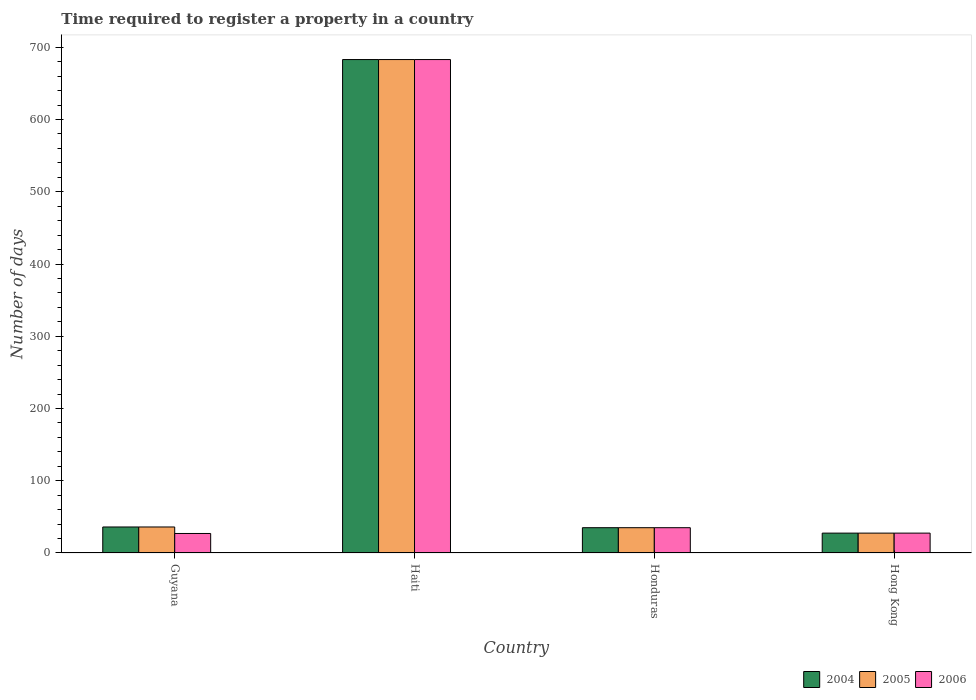How many different coloured bars are there?
Offer a terse response. 3. How many groups of bars are there?
Keep it short and to the point. 4. Are the number of bars per tick equal to the number of legend labels?
Provide a short and direct response. Yes. How many bars are there on the 1st tick from the right?
Offer a terse response. 3. What is the label of the 4th group of bars from the left?
Offer a very short reply. Hong Kong. In how many cases, is the number of bars for a given country not equal to the number of legend labels?
Ensure brevity in your answer.  0. What is the number of days required to register a property in 2006 in Haiti?
Make the answer very short. 683. Across all countries, what is the maximum number of days required to register a property in 2004?
Provide a succinct answer. 683. Across all countries, what is the minimum number of days required to register a property in 2004?
Your response must be concise. 27.5. In which country was the number of days required to register a property in 2004 maximum?
Ensure brevity in your answer.  Haiti. In which country was the number of days required to register a property in 2004 minimum?
Ensure brevity in your answer.  Hong Kong. What is the total number of days required to register a property in 2004 in the graph?
Provide a succinct answer. 781.5. What is the difference between the number of days required to register a property in 2006 in Guyana and that in Haiti?
Make the answer very short. -656. What is the average number of days required to register a property in 2004 per country?
Ensure brevity in your answer.  195.38. In how many countries, is the number of days required to register a property in 2004 greater than 80 days?
Your answer should be compact. 1. What is the ratio of the number of days required to register a property in 2005 in Honduras to that in Hong Kong?
Make the answer very short. 1.27. Is the number of days required to register a property in 2005 in Guyana less than that in Hong Kong?
Offer a very short reply. No. What is the difference between the highest and the lowest number of days required to register a property in 2005?
Keep it short and to the point. 655.5. In how many countries, is the number of days required to register a property in 2006 greater than the average number of days required to register a property in 2006 taken over all countries?
Ensure brevity in your answer.  1. What does the 1st bar from the left in Hong Kong represents?
Your answer should be compact. 2004. What does the 2nd bar from the right in Honduras represents?
Keep it short and to the point. 2005. How many bars are there?
Ensure brevity in your answer.  12. Are all the bars in the graph horizontal?
Offer a very short reply. No. How many countries are there in the graph?
Keep it short and to the point. 4. What is the difference between two consecutive major ticks on the Y-axis?
Offer a very short reply. 100. Does the graph contain any zero values?
Offer a very short reply. No. How are the legend labels stacked?
Provide a short and direct response. Horizontal. What is the title of the graph?
Provide a succinct answer. Time required to register a property in a country. Does "1964" appear as one of the legend labels in the graph?
Provide a succinct answer. No. What is the label or title of the Y-axis?
Provide a short and direct response. Number of days. What is the Number of days in 2004 in Guyana?
Provide a short and direct response. 36. What is the Number of days of 2006 in Guyana?
Give a very brief answer. 27. What is the Number of days in 2004 in Haiti?
Offer a very short reply. 683. What is the Number of days of 2005 in Haiti?
Provide a succinct answer. 683. What is the Number of days in 2006 in Haiti?
Give a very brief answer. 683. What is the Number of days of 2006 in Honduras?
Provide a short and direct response. 35. What is the Number of days in 2004 in Hong Kong?
Give a very brief answer. 27.5. What is the Number of days in 2005 in Hong Kong?
Ensure brevity in your answer.  27.5. Across all countries, what is the maximum Number of days of 2004?
Offer a very short reply. 683. Across all countries, what is the maximum Number of days of 2005?
Make the answer very short. 683. Across all countries, what is the maximum Number of days of 2006?
Provide a short and direct response. 683. What is the total Number of days in 2004 in the graph?
Provide a short and direct response. 781.5. What is the total Number of days in 2005 in the graph?
Your answer should be very brief. 781.5. What is the total Number of days in 2006 in the graph?
Provide a succinct answer. 772.5. What is the difference between the Number of days of 2004 in Guyana and that in Haiti?
Give a very brief answer. -647. What is the difference between the Number of days in 2005 in Guyana and that in Haiti?
Ensure brevity in your answer.  -647. What is the difference between the Number of days in 2006 in Guyana and that in Haiti?
Provide a short and direct response. -656. What is the difference between the Number of days of 2005 in Guyana and that in Honduras?
Give a very brief answer. 1. What is the difference between the Number of days in 2006 in Guyana and that in Honduras?
Your response must be concise. -8. What is the difference between the Number of days in 2004 in Haiti and that in Honduras?
Your response must be concise. 648. What is the difference between the Number of days of 2005 in Haiti and that in Honduras?
Make the answer very short. 648. What is the difference between the Number of days in 2006 in Haiti and that in Honduras?
Provide a succinct answer. 648. What is the difference between the Number of days in 2004 in Haiti and that in Hong Kong?
Offer a very short reply. 655.5. What is the difference between the Number of days of 2005 in Haiti and that in Hong Kong?
Provide a short and direct response. 655.5. What is the difference between the Number of days of 2006 in Haiti and that in Hong Kong?
Your response must be concise. 655.5. What is the difference between the Number of days of 2004 in Guyana and the Number of days of 2005 in Haiti?
Make the answer very short. -647. What is the difference between the Number of days in 2004 in Guyana and the Number of days in 2006 in Haiti?
Keep it short and to the point. -647. What is the difference between the Number of days of 2005 in Guyana and the Number of days of 2006 in Haiti?
Your answer should be very brief. -647. What is the difference between the Number of days in 2004 in Guyana and the Number of days in 2005 in Honduras?
Keep it short and to the point. 1. What is the difference between the Number of days of 2004 in Guyana and the Number of days of 2006 in Honduras?
Your answer should be very brief. 1. What is the difference between the Number of days of 2005 in Guyana and the Number of days of 2006 in Honduras?
Offer a terse response. 1. What is the difference between the Number of days in 2004 in Guyana and the Number of days in 2005 in Hong Kong?
Your response must be concise. 8.5. What is the difference between the Number of days of 2004 in Guyana and the Number of days of 2006 in Hong Kong?
Offer a terse response. 8.5. What is the difference between the Number of days in 2005 in Guyana and the Number of days in 2006 in Hong Kong?
Ensure brevity in your answer.  8.5. What is the difference between the Number of days in 2004 in Haiti and the Number of days in 2005 in Honduras?
Your answer should be compact. 648. What is the difference between the Number of days of 2004 in Haiti and the Number of days of 2006 in Honduras?
Give a very brief answer. 648. What is the difference between the Number of days of 2005 in Haiti and the Number of days of 2006 in Honduras?
Ensure brevity in your answer.  648. What is the difference between the Number of days in 2004 in Haiti and the Number of days in 2005 in Hong Kong?
Ensure brevity in your answer.  655.5. What is the difference between the Number of days in 2004 in Haiti and the Number of days in 2006 in Hong Kong?
Offer a terse response. 655.5. What is the difference between the Number of days in 2005 in Haiti and the Number of days in 2006 in Hong Kong?
Provide a short and direct response. 655.5. What is the difference between the Number of days of 2004 in Honduras and the Number of days of 2005 in Hong Kong?
Offer a very short reply. 7.5. What is the difference between the Number of days in 2004 in Honduras and the Number of days in 2006 in Hong Kong?
Offer a very short reply. 7.5. What is the difference between the Number of days of 2005 in Honduras and the Number of days of 2006 in Hong Kong?
Keep it short and to the point. 7.5. What is the average Number of days in 2004 per country?
Your answer should be very brief. 195.38. What is the average Number of days in 2005 per country?
Your answer should be very brief. 195.38. What is the average Number of days of 2006 per country?
Provide a succinct answer. 193.12. What is the difference between the Number of days of 2004 and Number of days of 2005 in Haiti?
Your answer should be very brief. 0. What is the difference between the Number of days of 2005 and Number of days of 2006 in Haiti?
Make the answer very short. 0. What is the difference between the Number of days in 2004 and Number of days in 2005 in Honduras?
Give a very brief answer. 0. What is the difference between the Number of days in 2004 and Number of days in 2005 in Hong Kong?
Make the answer very short. 0. What is the ratio of the Number of days in 2004 in Guyana to that in Haiti?
Offer a terse response. 0.05. What is the ratio of the Number of days of 2005 in Guyana to that in Haiti?
Give a very brief answer. 0.05. What is the ratio of the Number of days in 2006 in Guyana to that in Haiti?
Provide a succinct answer. 0.04. What is the ratio of the Number of days in 2004 in Guyana to that in Honduras?
Keep it short and to the point. 1.03. What is the ratio of the Number of days of 2005 in Guyana to that in Honduras?
Make the answer very short. 1.03. What is the ratio of the Number of days of 2006 in Guyana to that in Honduras?
Provide a short and direct response. 0.77. What is the ratio of the Number of days of 2004 in Guyana to that in Hong Kong?
Provide a succinct answer. 1.31. What is the ratio of the Number of days in 2005 in Guyana to that in Hong Kong?
Your answer should be very brief. 1.31. What is the ratio of the Number of days of 2006 in Guyana to that in Hong Kong?
Your answer should be very brief. 0.98. What is the ratio of the Number of days in 2004 in Haiti to that in Honduras?
Ensure brevity in your answer.  19.51. What is the ratio of the Number of days of 2005 in Haiti to that in Honduras?
Your response must be concise. 19.51. What is the ratio of the Number of days of 2006 in Haiti to that in Honduras?
Offer a very short reply. 19.51. What is the ratio of the Number of days of 2004 in Haiti to that in Hong Kong?
Ensure brevity in your answer.  24.84. What is the ratio of the Number of days of 2005 in Haiti to that in Hong Kong?
Provide a short and direct response. 24.84. What is the ratio of the Number of days of 2006 in Haiti to that in Hong Kong?
Provide a short and direct response. 24.84. What is the ratio of the Number of days in 2004 in Honduras to that in Hong Kong?
Keep it short and to the point. 1.27. What is the ratio of the Number of days of 2005 in Honduras to that in Hong Kong?
Offer a terse response. 1.27. What is the ratio of the Number of days in 2006 in Honduras to that in Hong Kong?
Ensure brevity in your answer.  1.27. What is the difference between the highest and the second highest Number of days of 2004?
Make the answer very short. 647. What is the difference between the highest and the second highest Number of days of 2005?
Your answer should be compact. 647. What is the difference between the highest and the second highest Number of days of 2006?
Keep it short and to the point. 648. What is the difference between the highest and the lowest Number of days of 2004?
Ensure brevity in your answer.  655.5. What is the difference between the highest and the lowest Number of days of 2005?
Make the answer very short. 655.5. What is the difference between the highest and the lowest Number of days of 2006?
Your answer should be compact. 656. 